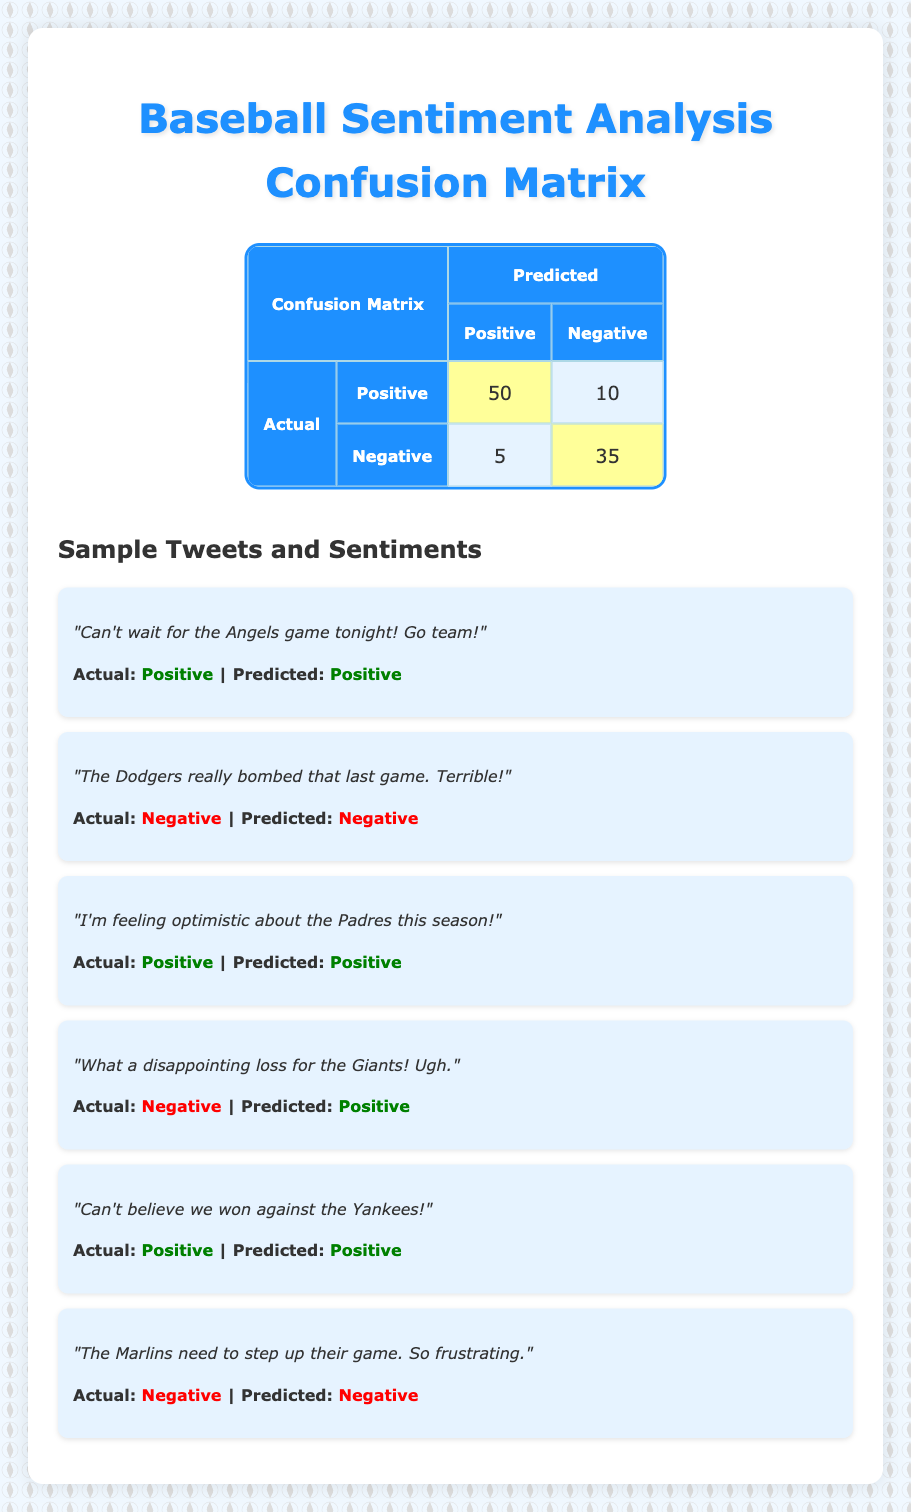What is the total number of actual positive cases? The actual positive cases are represented in the confusion matrix. Looking at the row for actual positive, we see 50 predicted positive and 10 predicted negative. To find the total, we sum these values: 50 + 10 = 60.
Answer: 60 How many tweets were classified as falsely positive? Falsely positive cases are when the actual sentiment is negative but predicted as positive. In the confusion matrix, there are 5 cases fitting this description, which is indicated by the cell where actual negative meets predicted positive.
Answer: 5 What is the overall accuracy of the sentiment analysis model? To find the overall accuracy, we calculate the total correct predictions (true positives and true negatives) divided by the total predictions. The correct predictions are 50 (true positive) + 35 (true negative) = 85. The total predictions are 50 + 10 + 5 + 35 = 100. Accuracy = 85/100 = 0.85, which is 85%.
Answer: 85% Are there more instances of true positives than true negatives? Looking at the confusion matrix, the true positives are 50, while the true negatives are 35. Since 50 > 35, the statement is true.
Answer: Yes What is the total number of actual negative cases? The actual negative cases are represented in the confusion matrix as 5 predicted positive cases and 35 predicted negative cases. To find the total, we sum these values: 5 + 35 = 40.
Answer: 40 What percentage of the predictions were accurate? To determine the percentage of accurate predictions, we calculate the formula: (Total correct predictions / Total predictions) * 100. The total correct is 85 (as previously calculated) and total predictions are 100. So, (85/100) * 100 = 85%.
Answer: 85% How many total predictions were made? The total number of predictions can be found by summing all values in the confusion matrix: 50 (true positive) + 10 (false negative) + 5 (false positive) + 35 (true negative) = 100.
Answer: 100 What is the ratio of false negatives to true positives? Looking at the confusion matrix, false negatives are represented by 10 (predicted negative) under actual positive, and true positives are represented by 50. Therefore, the ratio is 10:50 which simplifies to 1:5.
Answer: 1:5 Was the classification of "What a disappointing loss for the Giants! Ugh." correct? This tweet had an actual sentiment of negative but was predicted as positive, indicating a misclassification. Therefore, the classification was not correct.
Answer: No 